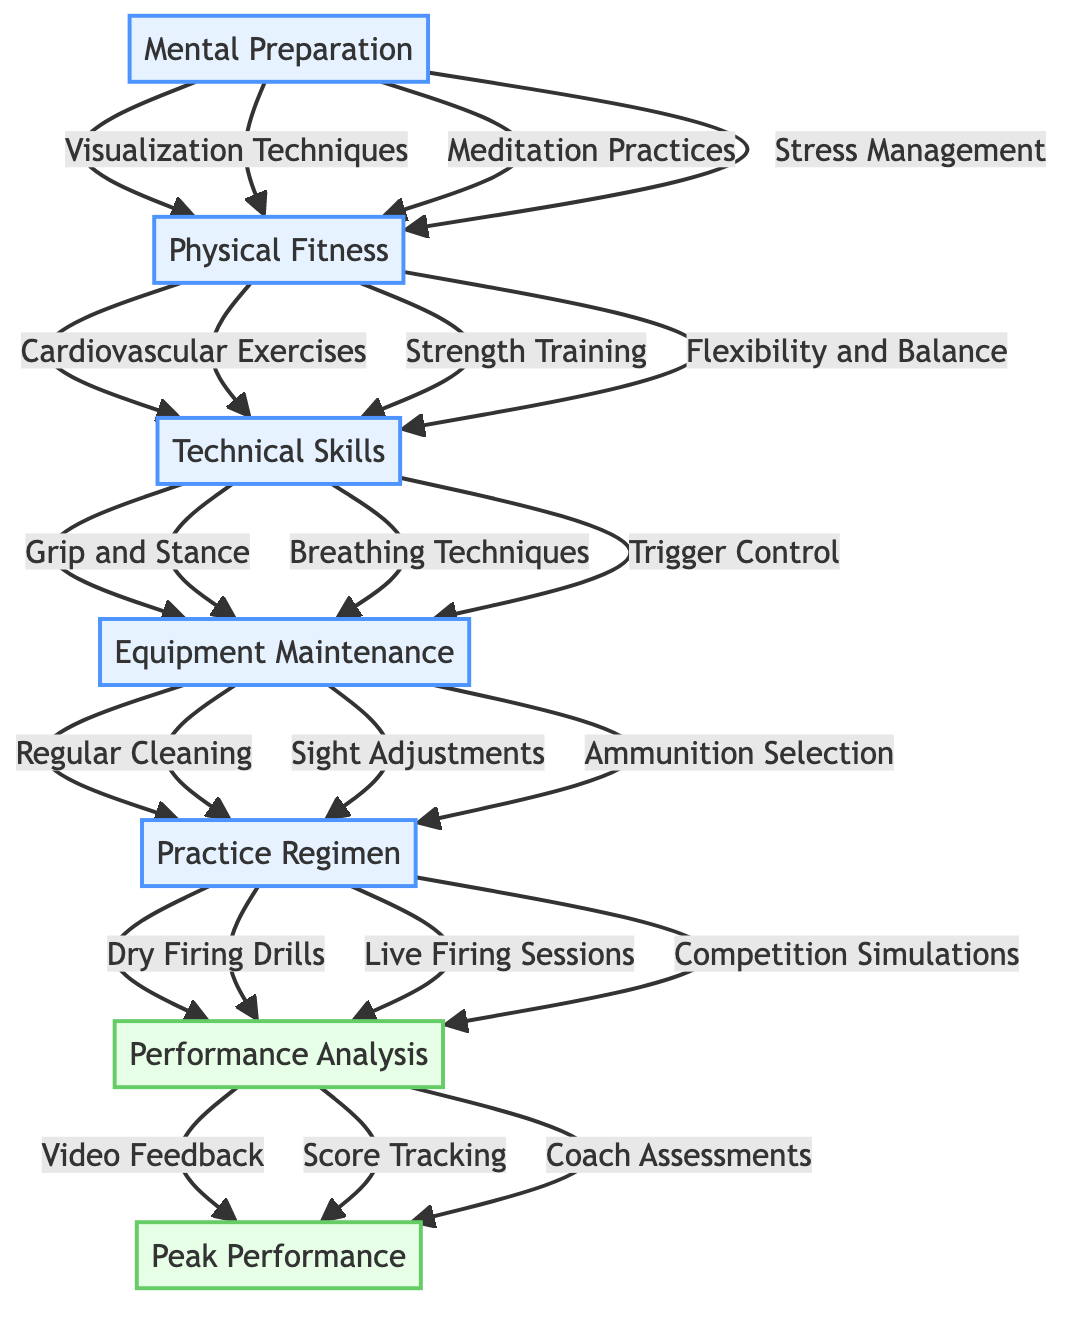What is the base element in the training routine? The base element, which forms the foundation of the training routine, is "Mental Preparation." This is directly stated in the diagram and is the lowest point before moving up towards the peak performance element.
Answer: Mental Preparation How many components are under Technical Skills? The Technical Skills section contains three components: "Grip and Stance," "Breathing Techniques," and "Trigger Control." By counting each of these listed components in the diagram, we find there are three.
Answer: 3 What is the immediate element above Physical Fitness? The element immediately above Physical Fitness in the flow chart is Technical Skills. This indicates the next step in the training routine that builds on the foundation of Physical Fitness.
Answer: Technical Skills Which practice is included in the Practice Regimen? The Practice Regimen includes "Dry Firing Drills." This is one of the three components listed under the Practice Regimen in the diagram.
Answer: Dry Firing Drills What type of analysis is performed at the peak of the routine? At the peak of the routine, "Performance Analysis" is conducted. This is represented at the highest point in the diagram, indicating it is the final step after completing all previous elements of the training routine.
Answer: Performance Analysis How many edges are there from Equipment Maintenance to Practice Regimen? There are three edges from Equipment Maintenance to Practice Regimen, corresponding to the three components: "Regular Cleaning," "Sight Adjustments," and "Ammunition Selection." Each component is directly linked to the Practice Regimen.
Answer: 3 Which component of Mental Preparation focuses on relaxation? "Meditation Practices" is the component under Mental Preparation that focuses on relaxation techniques. This is specified among the components listed.
Answer: Meditation Practices What are the components under Performance Analysis? The components under Performance Analysis are "Video Feedback," "Score Tracking," and "Coach Assessments." This list is provided in the diagram, representing the elements essential for analyzing performance.
Answer: Video Feedback, Score Tracking, Coach Assessments What element directly feeds into Equipment Maintenance? The element that directly feeds into Equipment Maintenance is Technical Skills, as indicated by the arrow pointing from Technical Skills to Equipment Maintenance.
Answer: Technical Skills 